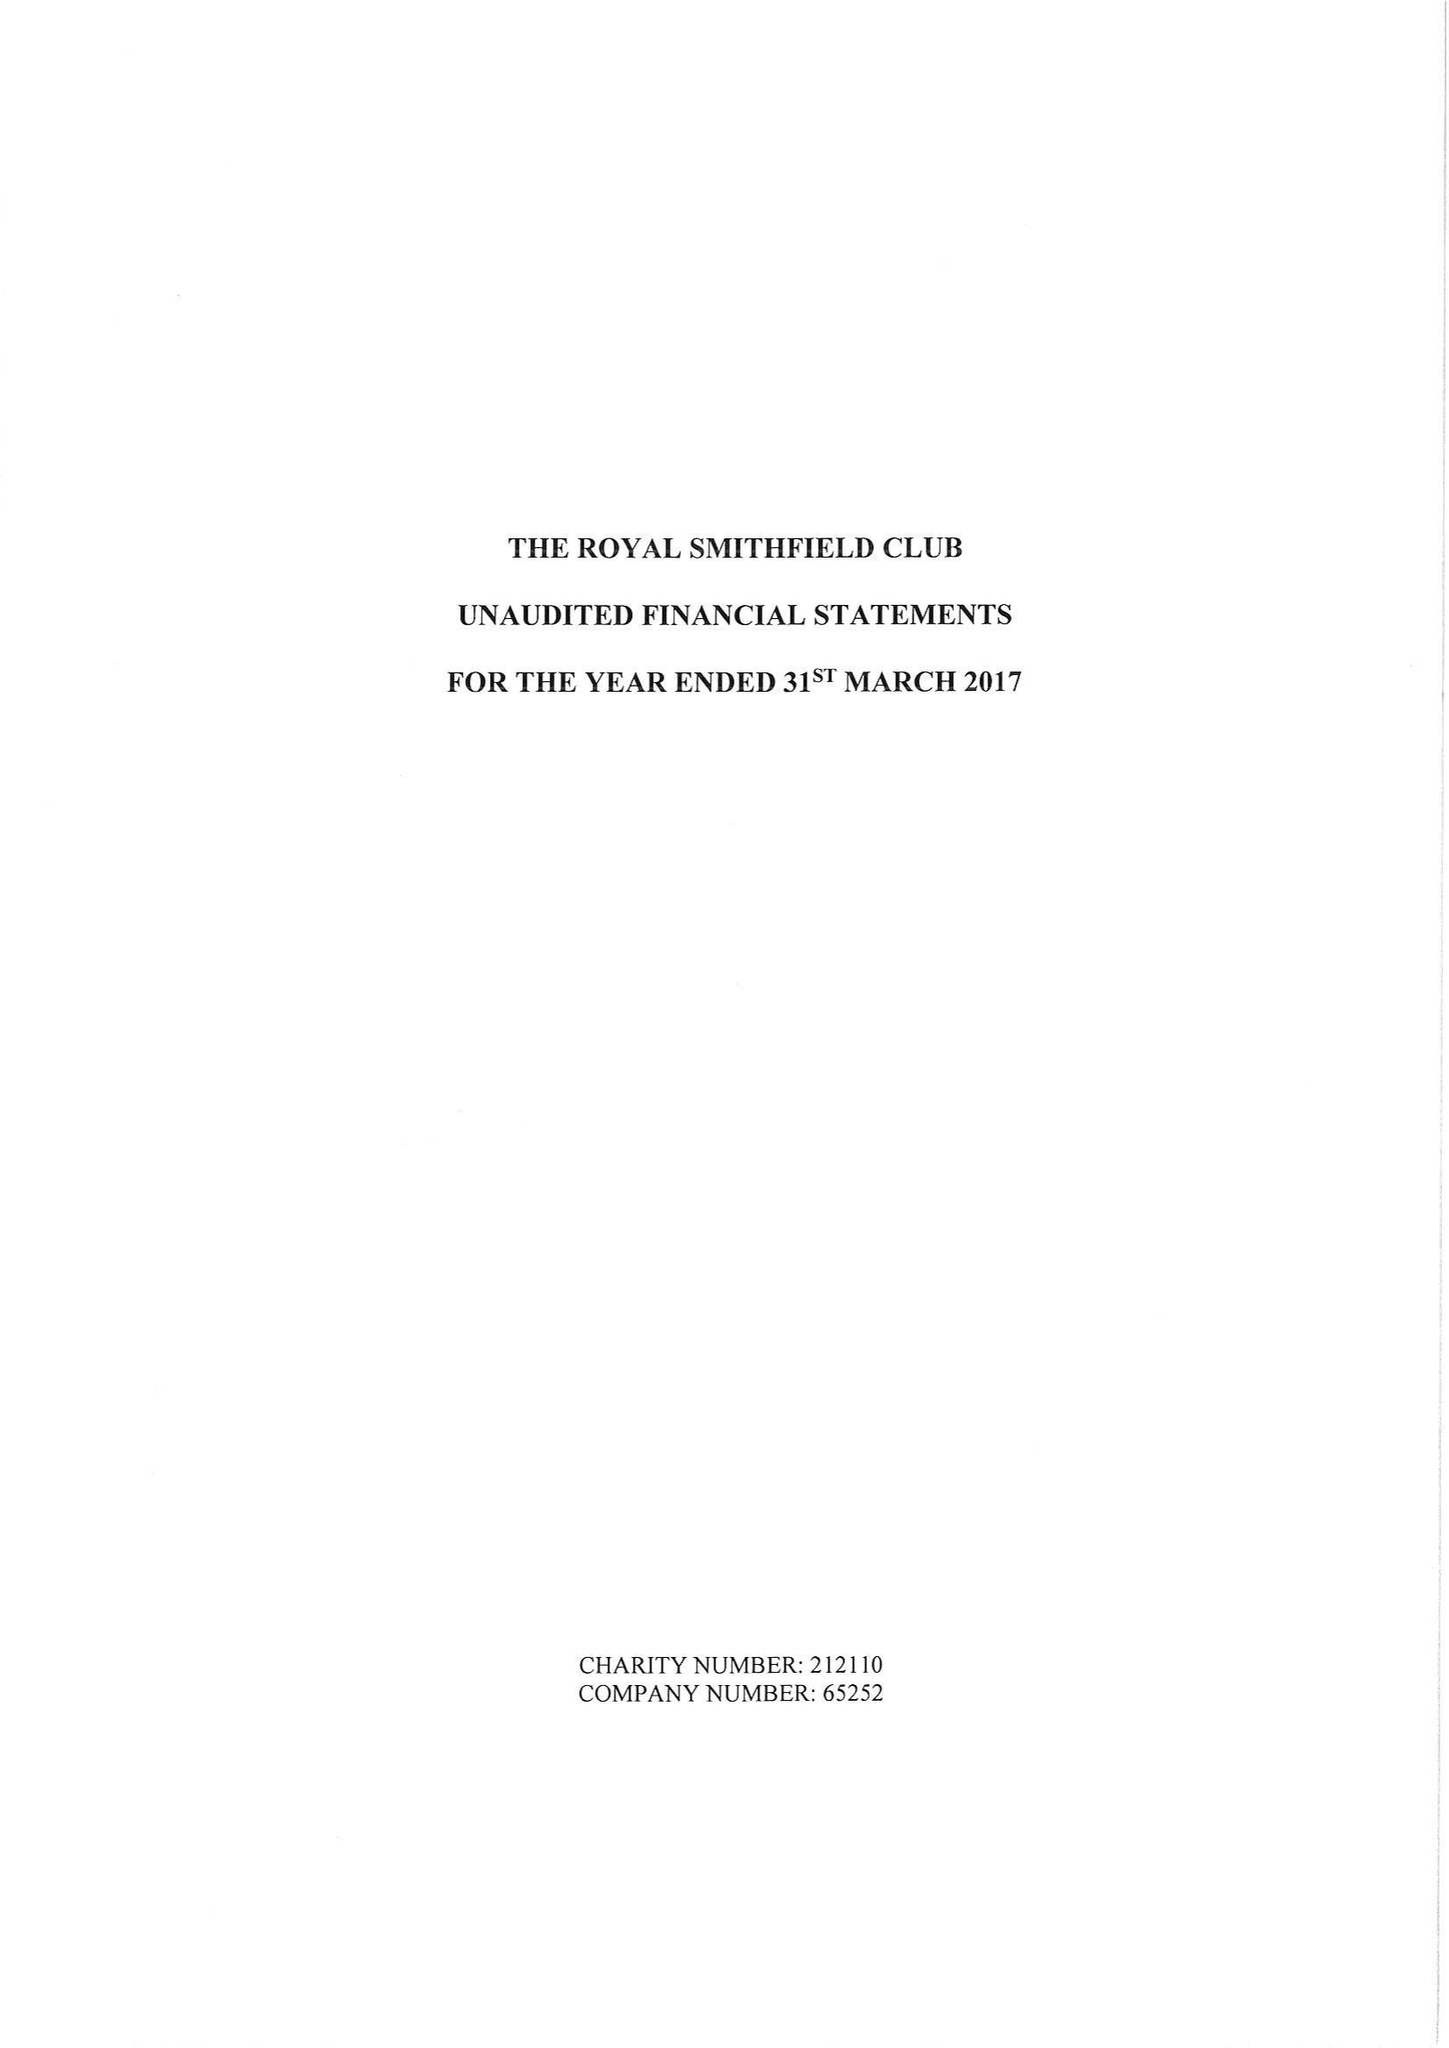What is the value for the charity_name?
Answer the question using a single word or phrase. The Royal Smithfield Club 